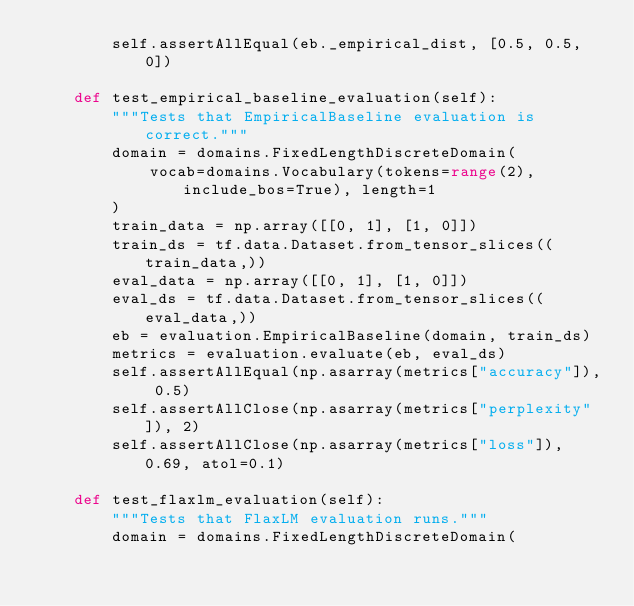Convert code to text. <code><loc_0><loc_0><loc_500><loc_500><_Python_>        self.assertAllEqual(eb._empirical_dist, [0.5, 0.5, 0])

    def test_empirical_baseline_evaluation(self):
        """Tests that EmpiricalBaseline evaluation is correct."""
        domain = domains.FixedLengthDiscreteDomain(
            vocab=domains.Vocabulary(tokens=range(2), include_bos=True), length=1
        )
        train_data = np.array([[0, 1], [1, 0]])
        train_ds = tf.data.Dataset.from_tensor_slices((train_data,))
        eval_data = np.array([[0, 1], [1, 0]])
        eval_ds = tf.data.Dataset.from_tensor_slices((eval_data,))
        eb = evaluation.EmpiricalBaseline(domain, train_ds)
        metrics = evaluation.evaluate(eb, eval_ds)
        self.assertAllEqual(np.asarray(metrics["accuracy"]), 0.5)
        self.assertAllClose(np.asarray(metrics["perplexity"]), 2)
        self.assertAllClose(np.asarray(metrics["loss"]), 0.69, atol=0.1)

    def test_flaxlm_evaluation(self):
        """Tests that FlaxLM evaluation runs."""
        domain = domains.FixedLengthDiscreteDomain(</code> 